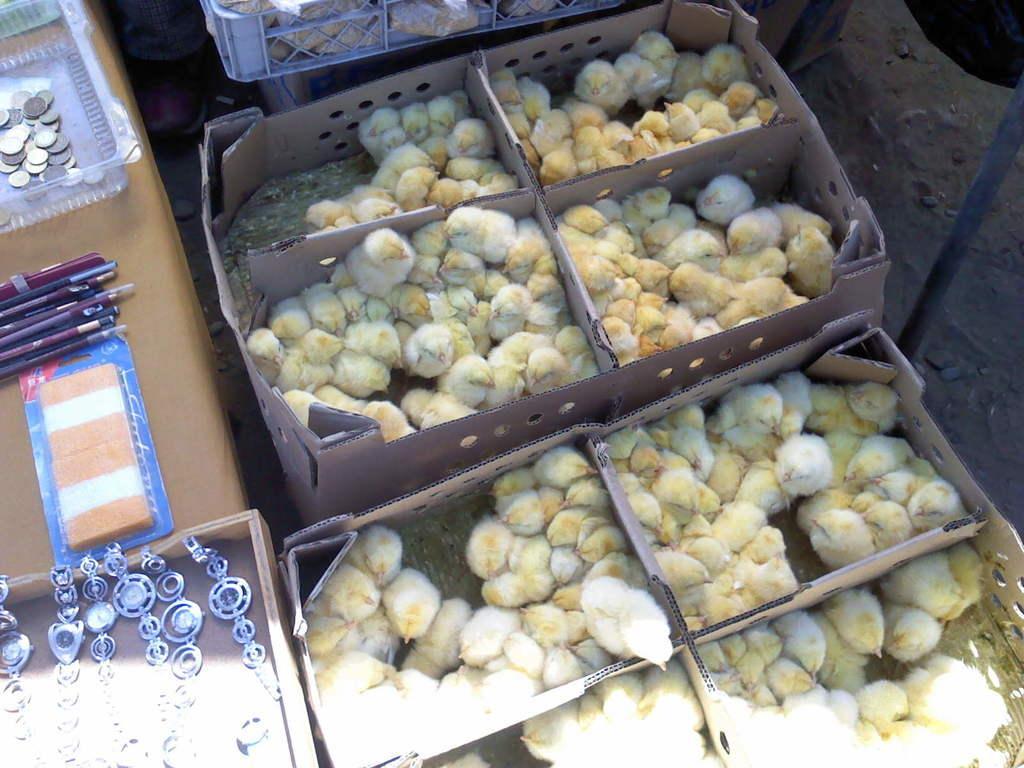Please provide a concise description of this image. In this image I can see many chicks in the cardboard boxes. To the left I can see the watches, pencils, coins and some objects. These are on the brown color surface. In the background I can see few more chicks in the boxes. 